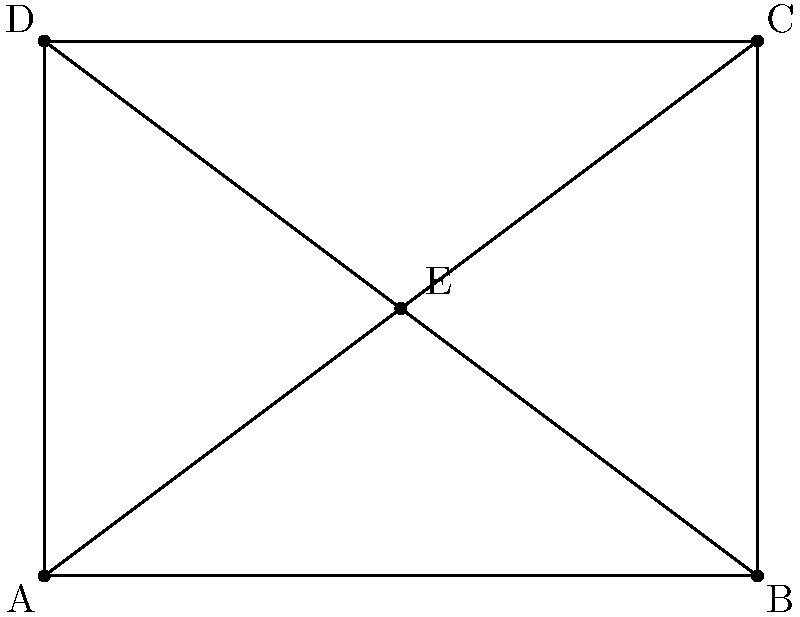In this simplified Fachwerk design, common in Baden-Württemberg architecture, all triangles formed by the diagonal beams are congruent. If the length of AB is 4 meters and the height of the structure (AD) is 3 meters, what is the length of AE in meters? To solve this problem, we'll follow these steps:

1) First, we need to recognize that triangles AEB and CED are congruent due to the properties of the Fachwerk design.

2) In right triangle ABD:
   $AB = 4$ m (given)
   $AD = 3$ m (given)
   
3) We can find BD using the Pythagorean theorem:
   $BD^2 = AB^2 + AD^2$
   $BD^2 = 4^2 + 3^2 = 16 + 9 = 25$
   $BD = 5$ m

4) Now, in triangle AEB:
   $AE : EB = AD : DB$
   This is because E is the midpoint of AC and BD.

5) We can set up the proportion:
   $\frac{AE}{EB} = \frac{3}{5}$

6) We also know that $AE + EB = AB = 4$

7) Let $AE = x$. Then $EB = 4 - x$

8) Substituting into the proportion:
   $\frac{x}{4-x} = \frac{3}{5}$

9) Cross multiply:
   $5x = 3(4-x) = 12 - 3x$

10) Solve the equation:
    $5x + 3x = 12$
    $8x = 12$
    $x = \frac{12}{8} = \frac{3}{2} = 1.5$

Therefore, AE = 1.5 meters.
Answer: 1.5 meters 